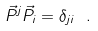<formula> <loc_0><loc_0><loc_500><loc_500>\vec { P } ^ { j } \vec { P } _ { i } = \delta _ { j i } \ .</formula> 